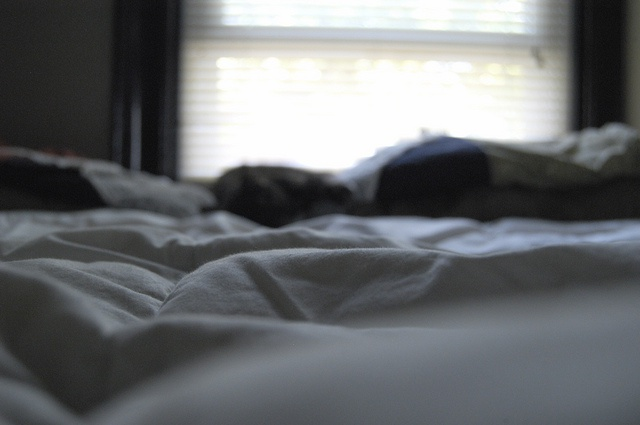Describe the objects in this image and their specific colors. I can see a bed in black and gray tones in this image. 